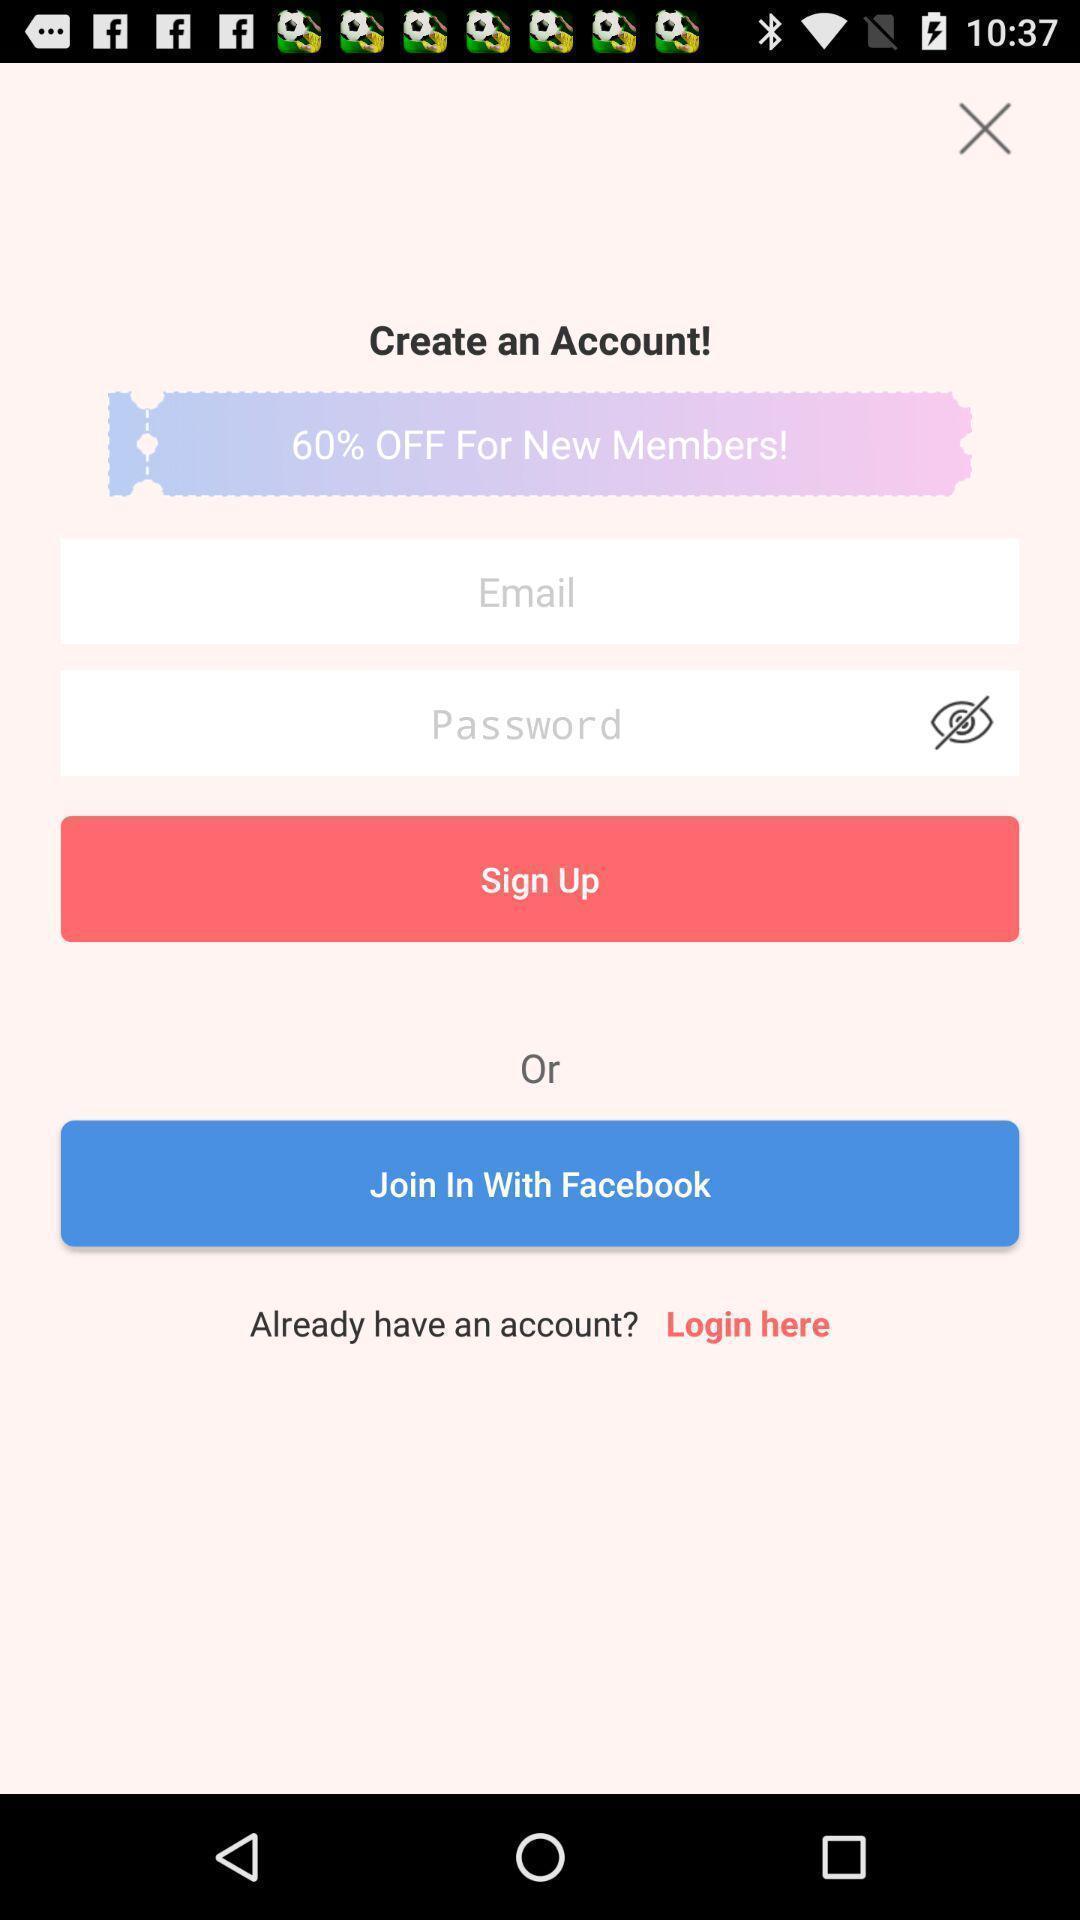Provide a description of this screenshot. Welcome page. 